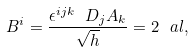<formula> <loc_0><loc_0><loc_500><loc_500>B ^ { i } = \frac { \epsilon ^ { i j k } \ D _ { j } A _ { k } } { \sqrt { h } } = 2 \ a l ,</formula> 